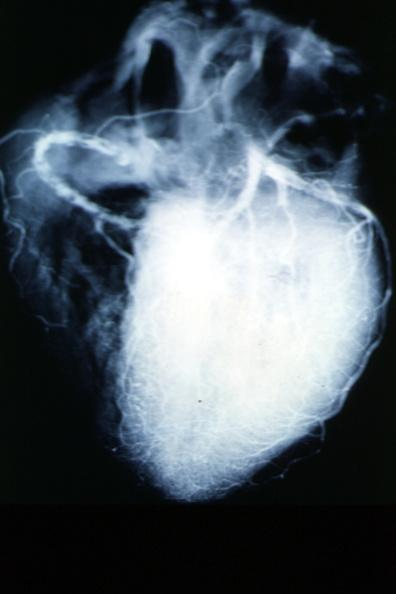does this image show x-ray postmortcoronary arteries with multiple lesions?
Answer the question using a single word or phrase. Yes 